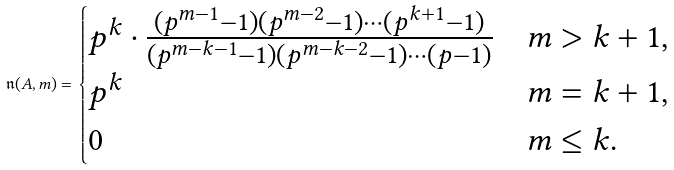<formula> <loc_0><loc_0><loc_500><loc_500>\mathfrak { n } ( A , m ) = \begin{cases} p ^ { k } \cdot \frac { ( p ^ { m - 1 } - 1 ) ( p ^ { m - 2 } - 1 ) \cdots ( p ^ { k + 1 } - 1 ) } { ( p ^ { m - k - 1 } - 1 ) ( p ^ { m - k - 2 } - 1 ) \cdots ( p - 1 ) } & m > k + 1 , \\ p ^ { k } & m = k + 1 , \\ 0 & m \leq k . \end{cases}</formula> 